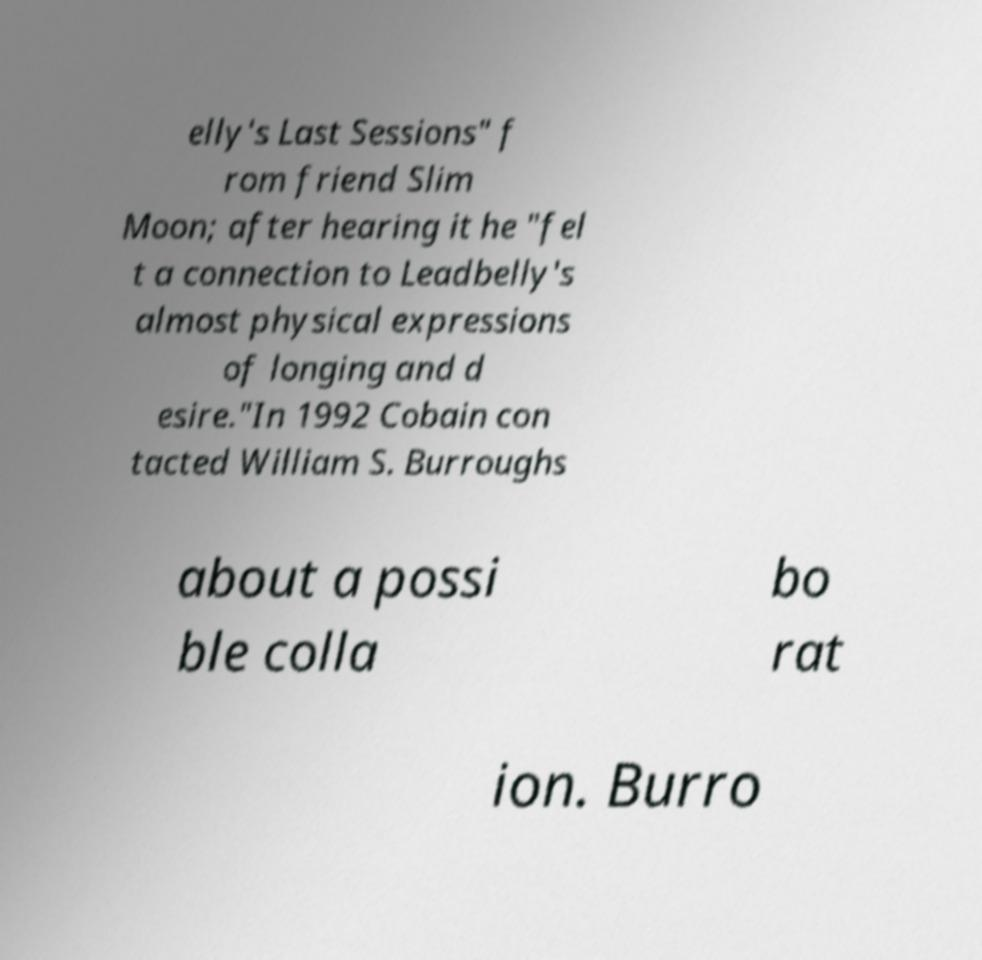There's text embedded in this image that I need extracted. Can you transcribe it verbatim? elly's Last Sessions" f rom friend Slim Moon; after hearing it he "fel t a connection to Leadbelly's almost physical expressions of longing and d esire."In 1992 Cobain con tacted William S. Burroughs about a possi ble colla bo rat ion. Burro 